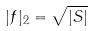<formula> <loc_0><loc_0><loc_500><loc_500>| f | _ { 2 } = \sqrt { | S | }</formula> 